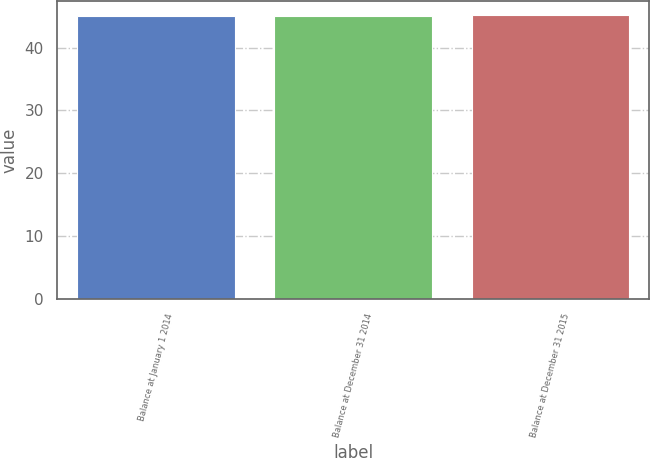Convert chart to OTSL. <chart><loc_0><loc_0><loc_500><loc_500><bar_chart><fcel>Balance at January 1 2014<fcel>Balance at December 31 2014<fcel>Balance at December 31 2015<nl><fcel>45<fcel>45.1<fcel>45.2<nl></chart> 